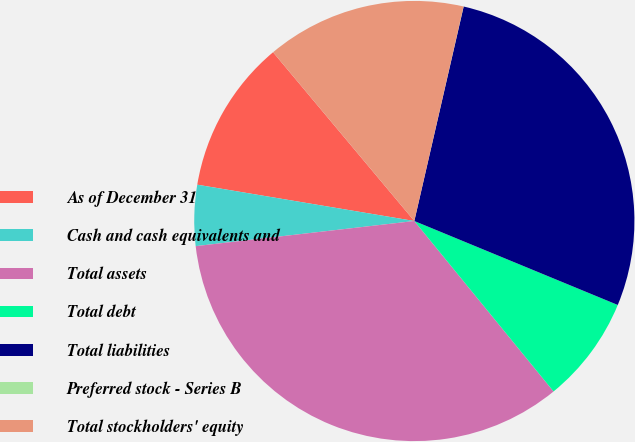<chart> <loc_0><loc_0><loc_500><loc_500><pie_chart><fcel>As of December 31<fcel>Cash and cash equivalents and<fcel>Total assets<fcel>Total debt<fcel>Total liabilities<fcel>Preferred stock - Series B<fcel>Total stockholders' equity<nl><fcel>11.27%<fcel>4.46%<fcel>34.08%<fcel>7.87%<fcel>27.63%<fcel>0.01%<fcel>14.68%<nl></chart> 